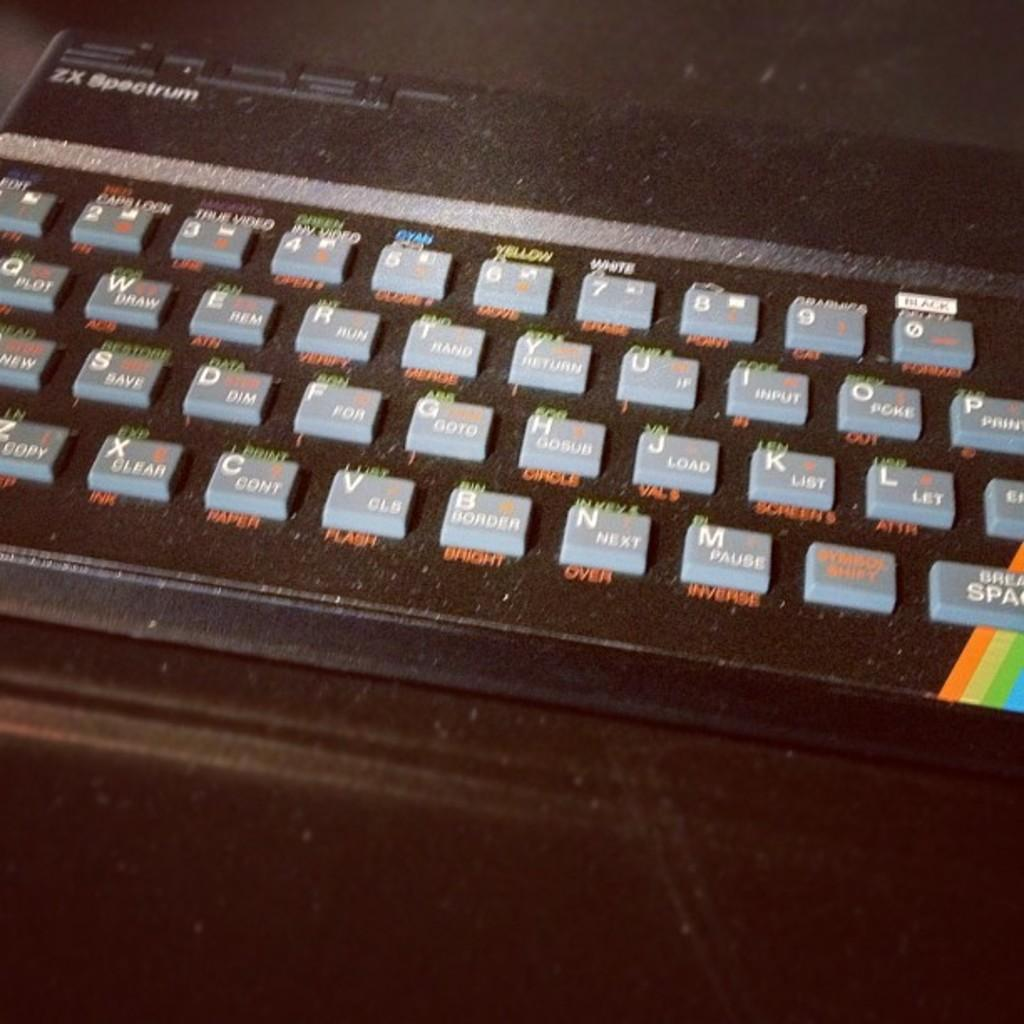<image>
Create a compact narrative representing the image presented. An old ZX Spectrum keyboard rests on a dark surface. 